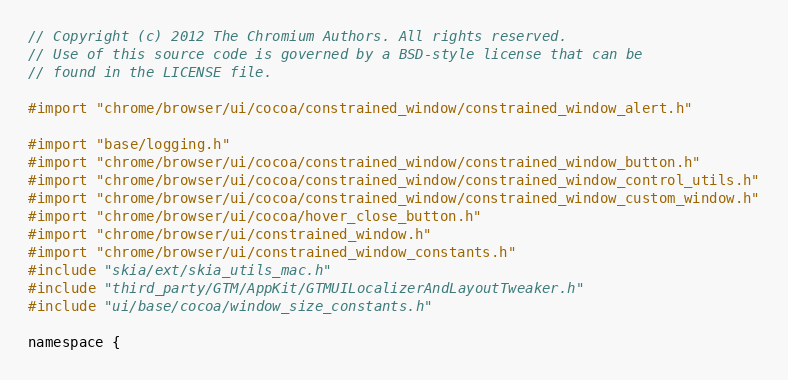<code> <loc_0><loc_0><loc_500><loc_500><_ObjectiveC_>// Copyright (c) 2012 The Chromium Authors. All rights reserved.
// Use of this source code is governed by a BSD-style license that can be
// found in the LICENSE file.

#import "chrome/browser/ui/cocoa/constrained_window/constrained_window_alert.h"

#import "base/logging.h"
#import "chrome/browser/ui/cocoa/constrained_window/constrained_window_button.h"
#import "chrome/browser/ui/cocoa/constrained_window/constrained_window_control_utils.h"
#import "chrome/browser/ui/cocoa/constrained_window/constrained_window_custom_window.h"
#import "chrome/browser/ui/cocoa/hover_close_button.h"
#import "chrome/browser/ui/constrained_window.h"
#import "chrome/browser/ui/constrained_window_constants.h"
#include "skia/ext/skia_utils_mac.h"
#include "third_party/GTM/AppKit/GTMUILocalizerAndLayoutTweaker.h"
#include "ui/base/cocoa/window_size_constants.h"

namespace {
</code> 